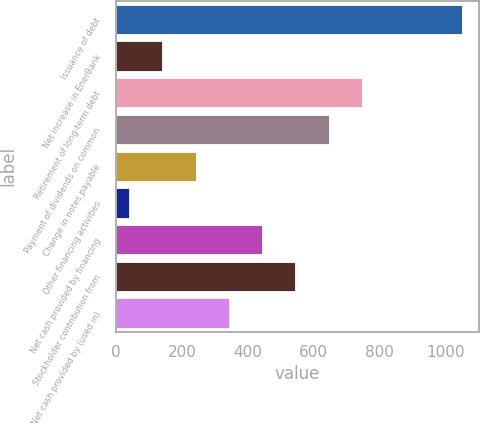Convert chart to OTSL. <chart><loc_0><loc_0><loc_500><loc_500><bar_chart><fcel>Issuance of debt<fcel>Net increase in EnerBank<fcel>Retirement of long-term debt<fcel>Payment of dividends on common<fcel>Change in notes payable<fcel>Other financing activities<fcel>Net cash provided by financing<fcel>Stockholder contribution from<fcel>Net cash provided by (used in)<nl><fcel>1049<fcel>140.9<fcel>746.3<fcel>645.4<fcel>241.8<fcel>40<fcel>443.6<fcel>544.5<fcel>342.7<nl></chart> 